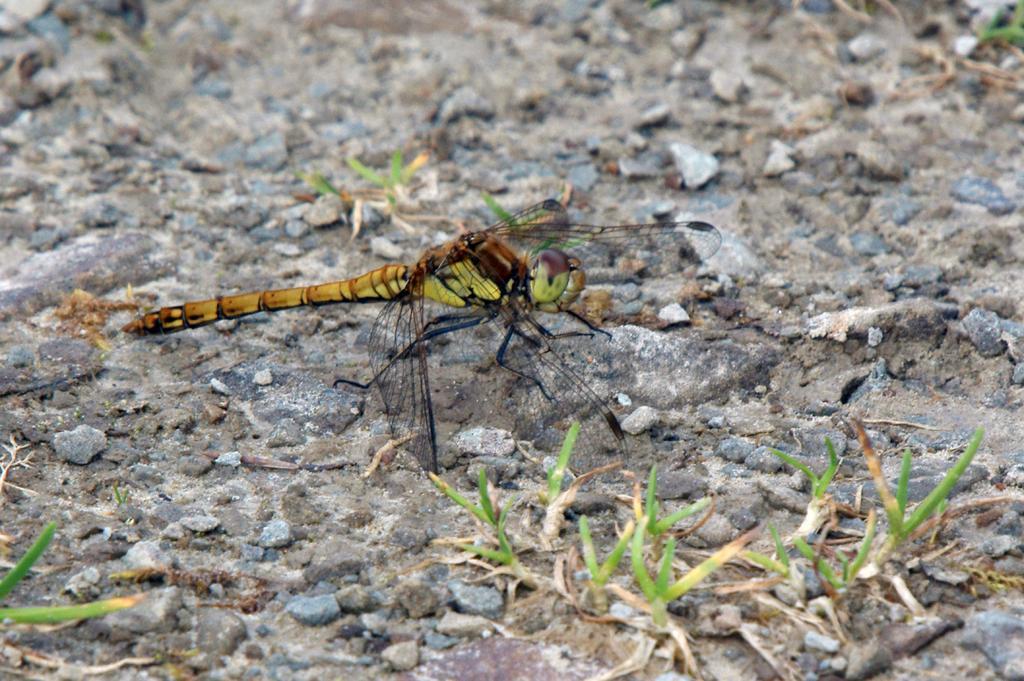In one or two sentences, can you explain what this image depicts? In this picture we can see the yellow and brown color grasshopper sitting on the ground. In the front we can see the small grass. 